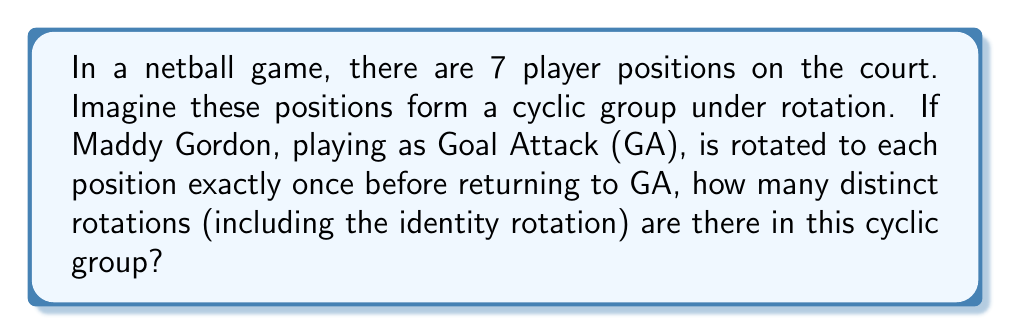What is the answer to this math problem? Let's approach this step-by-step:

1) In a cyclic group, the number of distinct rotations is equal to the order of the group.

2) The order of a cyclic group is equal to the number of elements in the group.

3) In this case, we have 7 player positions in netball:
   - Goal Shooter (GS)
   - Goal Attack (GA)
   - Wing Attack (WA)
   - Centre (C)
   - Wing Defence (WD)
   - Goal Defence (GD)
   - Goal Keeper (GK)

4) Each rotation moves every player to a new position. The rotations are:
   - Identity rotation (0 steps)
   - Rotate 1 position
   - Rotate 2 positions
   - Rotate 3 positions
   - Rotate 4 positions
   - Rotate 5 positions
   - Rotate 6 positions

5) After 7 rotations, we return to the original configuration, so this is equivalent to the identity rotation.

6) Therefore, the number of distinct rotations is 7.

7) In group theory notation, this cyclic group can be written as $C_7$ or $\mathbb{Z}/7\mathbb{Z}$.

8) The group operation table for this cyclic group would be a 7x7 matrix, with entries $a_{ij} = (i + j) \mod 7$ where $i, j \in \{0, 1, 2, 3, 4, 5, 6\}$.
Answer: The cyclic group representing netball player positions has 7 distinct rotations. 